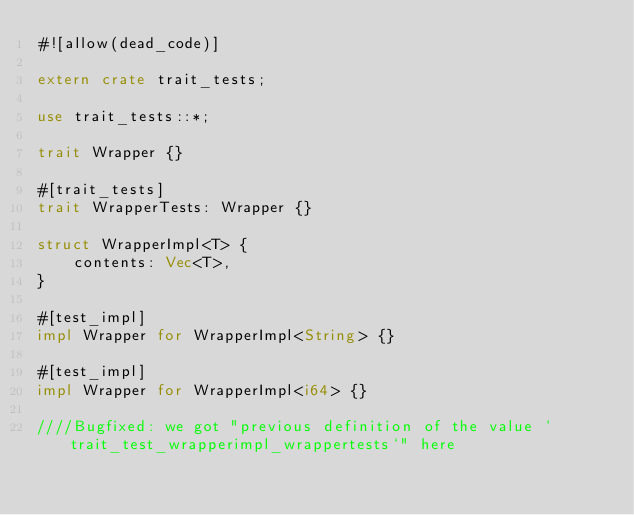<code> <loc_0><loc_0><loc_500><loc_500><_Rust_>#![allow(dead_code)]

extern crate trait_tests;

use trait_tests::*;

trait Wrapper {}

#[trait_tests]
trait WrapperTests: Wrapper {}

struct WrapperImpl<T> {
    contents: Vec<T>,
}

#[test_impl]
impl Wrapper for WrapperImpl<String> {}

#[test_impl]
impl Wrapper for WrapperImpl<i64> {}

////Bugfixed: we got "previous definition of the value `trait_test_wrapperimpl_wrappertests`" here
</code> 